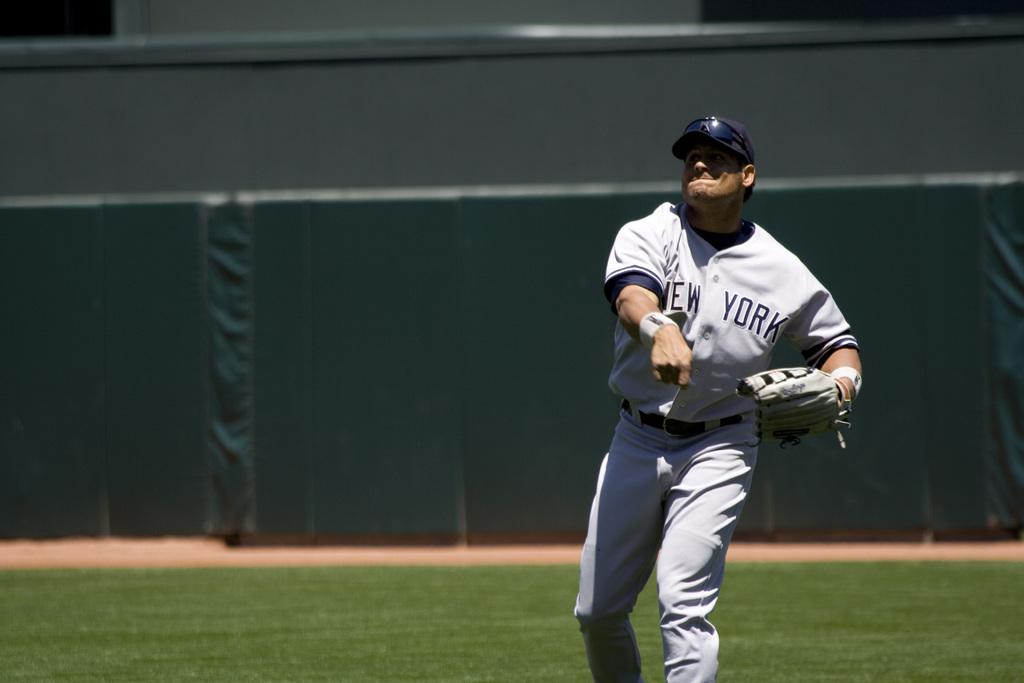<image>
Create a compact narrative representing the image presented. A baseball player in a New York shirt throwing a ball. 